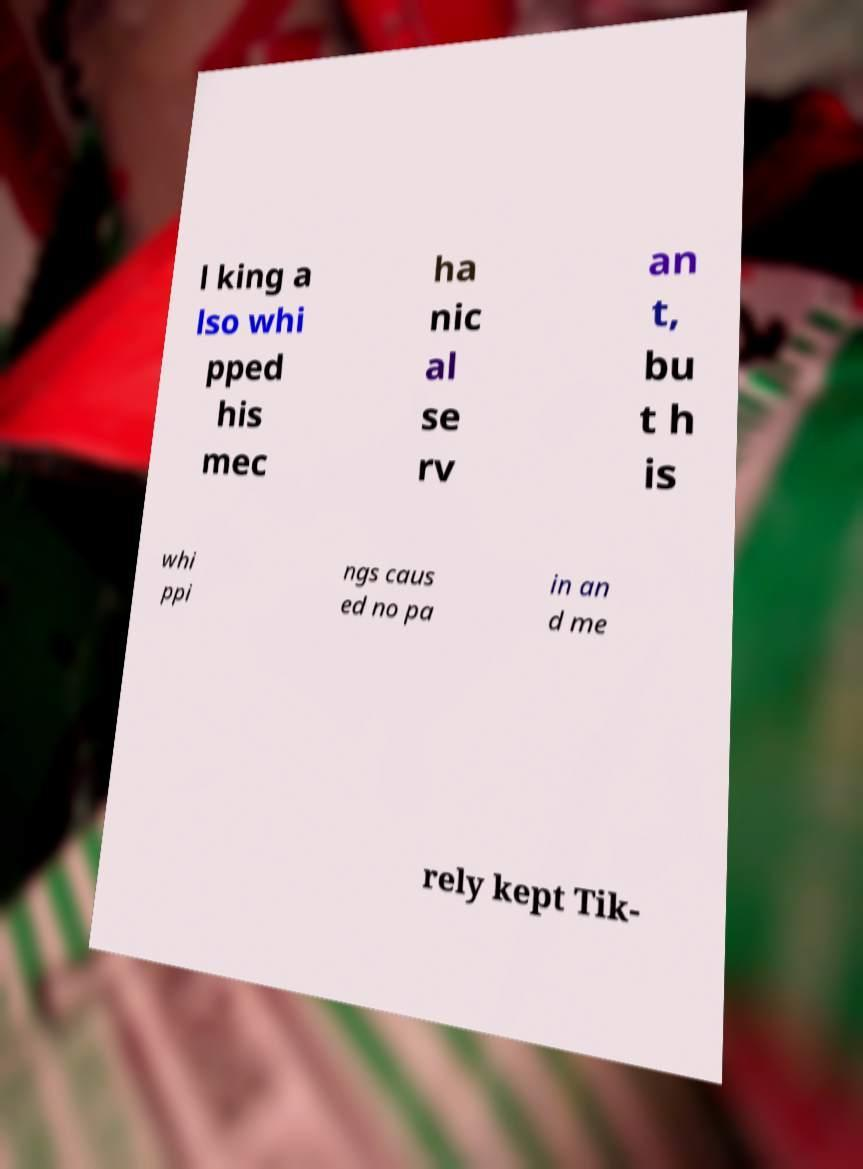For documentation purposes, I need the text within this image transcribed. Could you provide that? l king a lso whi pped his mec ha nic al se rv an t, bu t h is whi ppi ngs caus ed no pa in an d me rely kept Tik- 